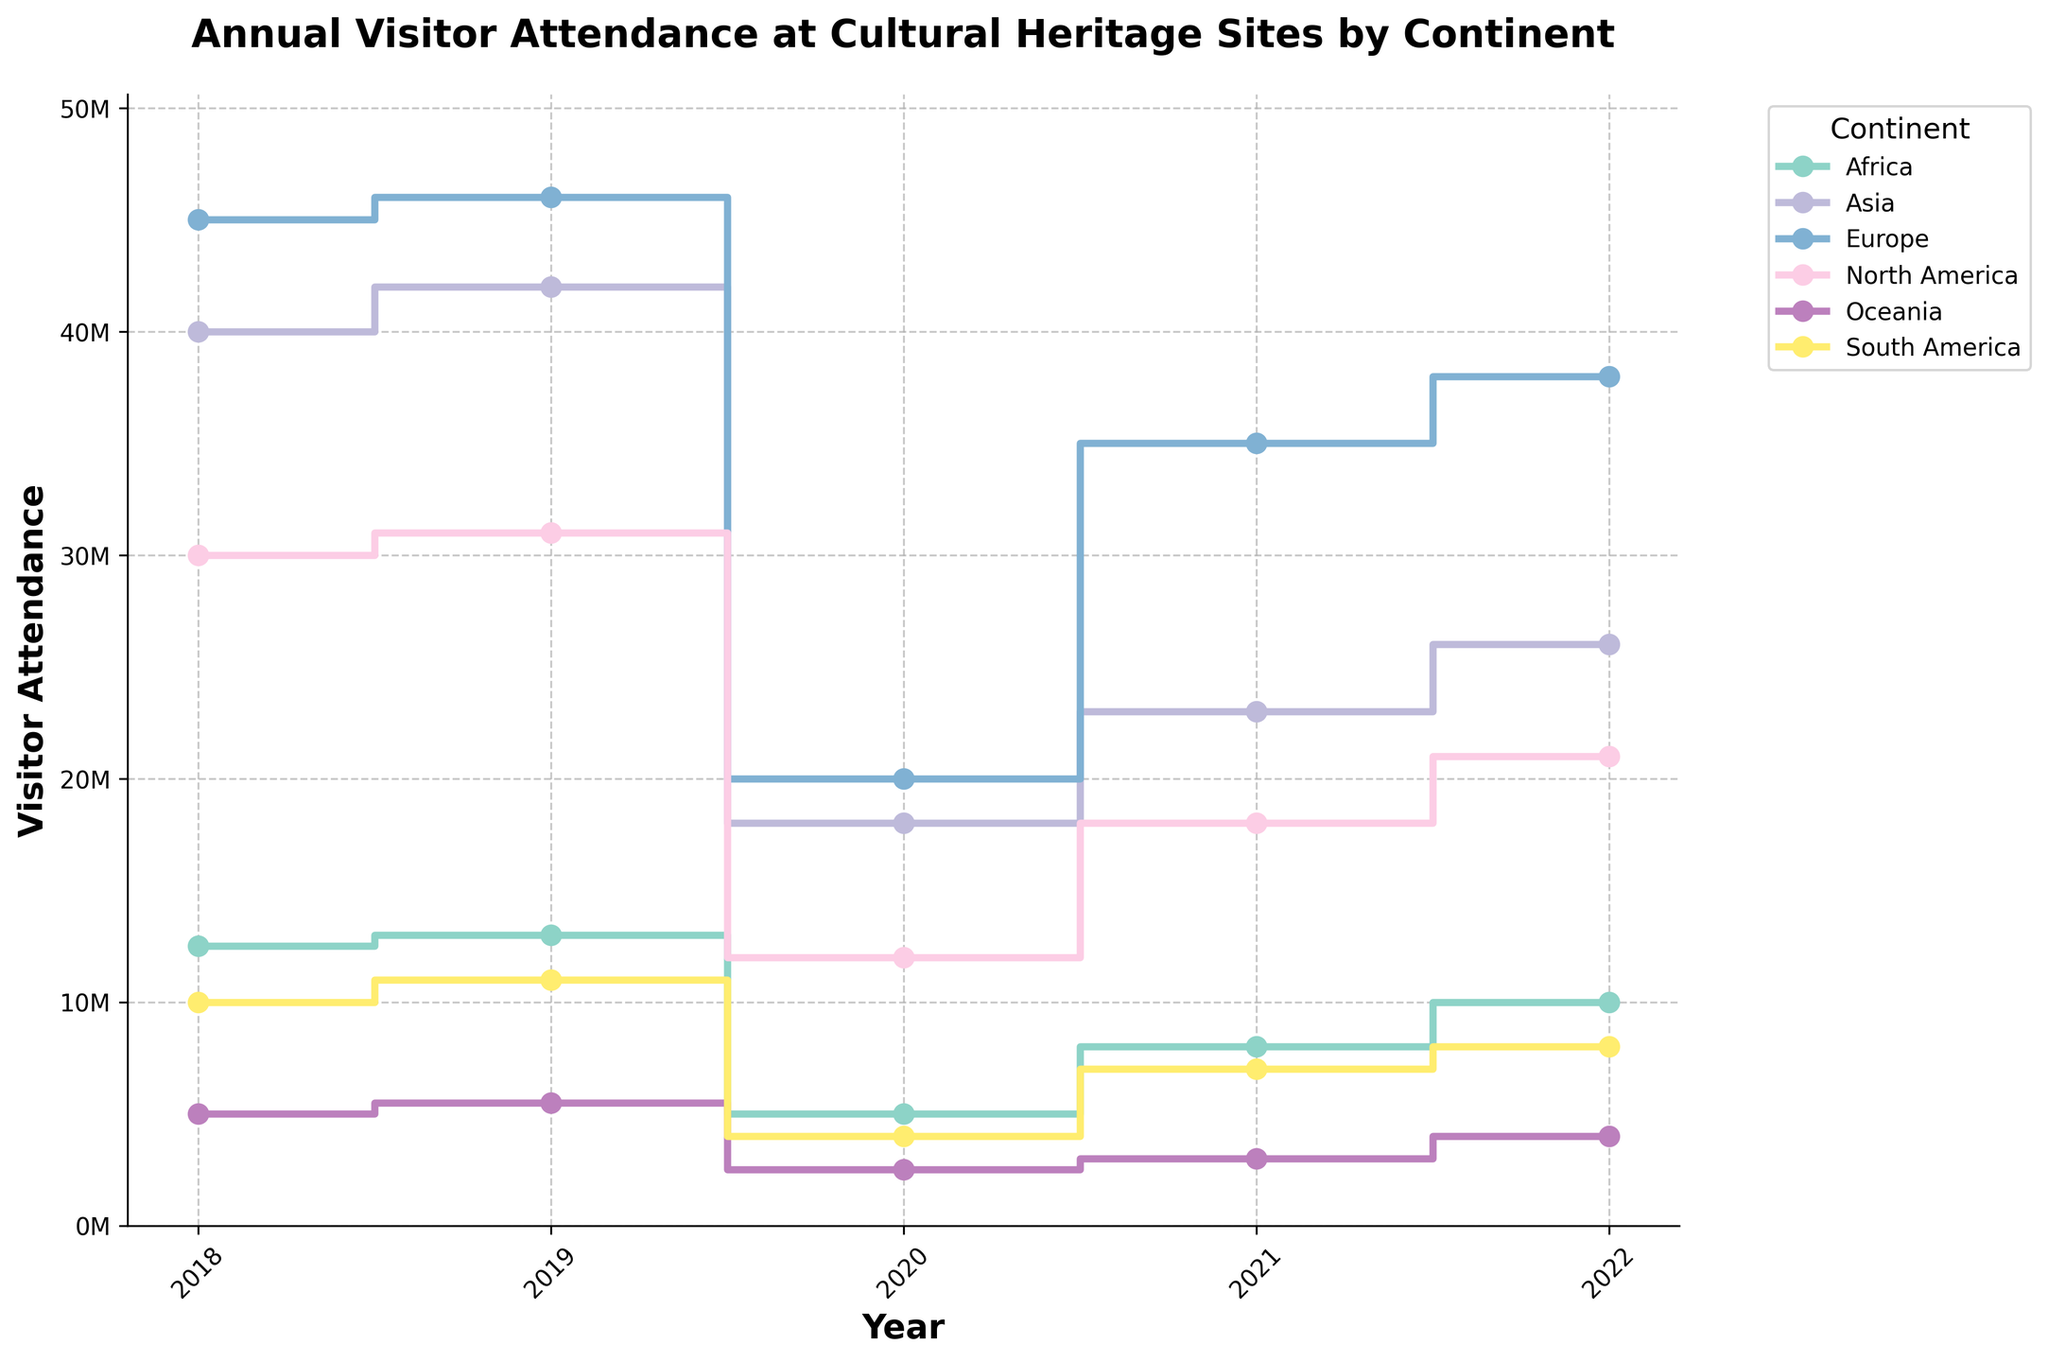What is the title of the plot? The title of the plot is written at the top and reads 'Annual Visitor Attendance at Cultural Heritage Sites by Continent.'
Answer: Annual Visitor Attendance at Cultural Heritage Sites by Continent Which continent had the highest visitor attendance in 2019? By looking at the stair plot, we can see that Europe had the highest visitor attendance in 2019.
Answer: Europe What is the visitor attendance range for Africa between 2018 and 2022? To find the range, we subtracted the minimum attendance value from the maximum attendance value for Africa. Maximum: 13,000,000 (2019), Minimum: 5,000,000 (2020), Range = 13,000,000 - 5,000,000 = 8,000,000
Answer: 8,000,000 How did visitor attendance in South America change from 2020 to 2021? Observing the stair steps for South America, we see that attendance increased from 4,000,000 in 2020 to 7,000,000 in 2021, an increase of 3,000,000.
Answer: Increased by 3,000,000 Which years showed a decrease in visitor attendance in North America? By tracing the North American line on the stair plot, the years 2020 and 2021 indicate a decrease from the previous year: 2019 (31,000,000) to 2020 (12,000,000) and 2020 (12,000,000) to 2021 (18,000,000 is an increase.
Answer: 2020 What was the attendance in Asia in 2022 compared to 2018? The plot shows Asia had 40,000,000 visitors in 2018 and 26,000,000 in 2022. The difference is 40,000,000 - 26,000,000 = 14,000,000.
Answer: Decreased by 14,000,000 What pattern is observed in Europe's visitor attendance from 2018 to 2022? From 2018 to 2019, attendance increased. There is a sharp decrease in 2020, followed by a significant recovery over 2021 and 2022, but it does not surpass the 2018-2019 levels.
Answer: Decrease followed by recovery Which continent had a consistent increase in visitor attendance after 2020? By examining the plot, Oceania shows a consistent increase in visitor attendance after 2020 from 2,500,000 in 2020 to 4,000,000 in 2022.
Answer: Oceania What was the overall trend for visitor attendance across all continents from 2019 to 2020? By comparing the steps from 2019 to 2020 for all continents, we see a significant decrease in visitor attendance in all continents.
Answer: Decrease across all continents 